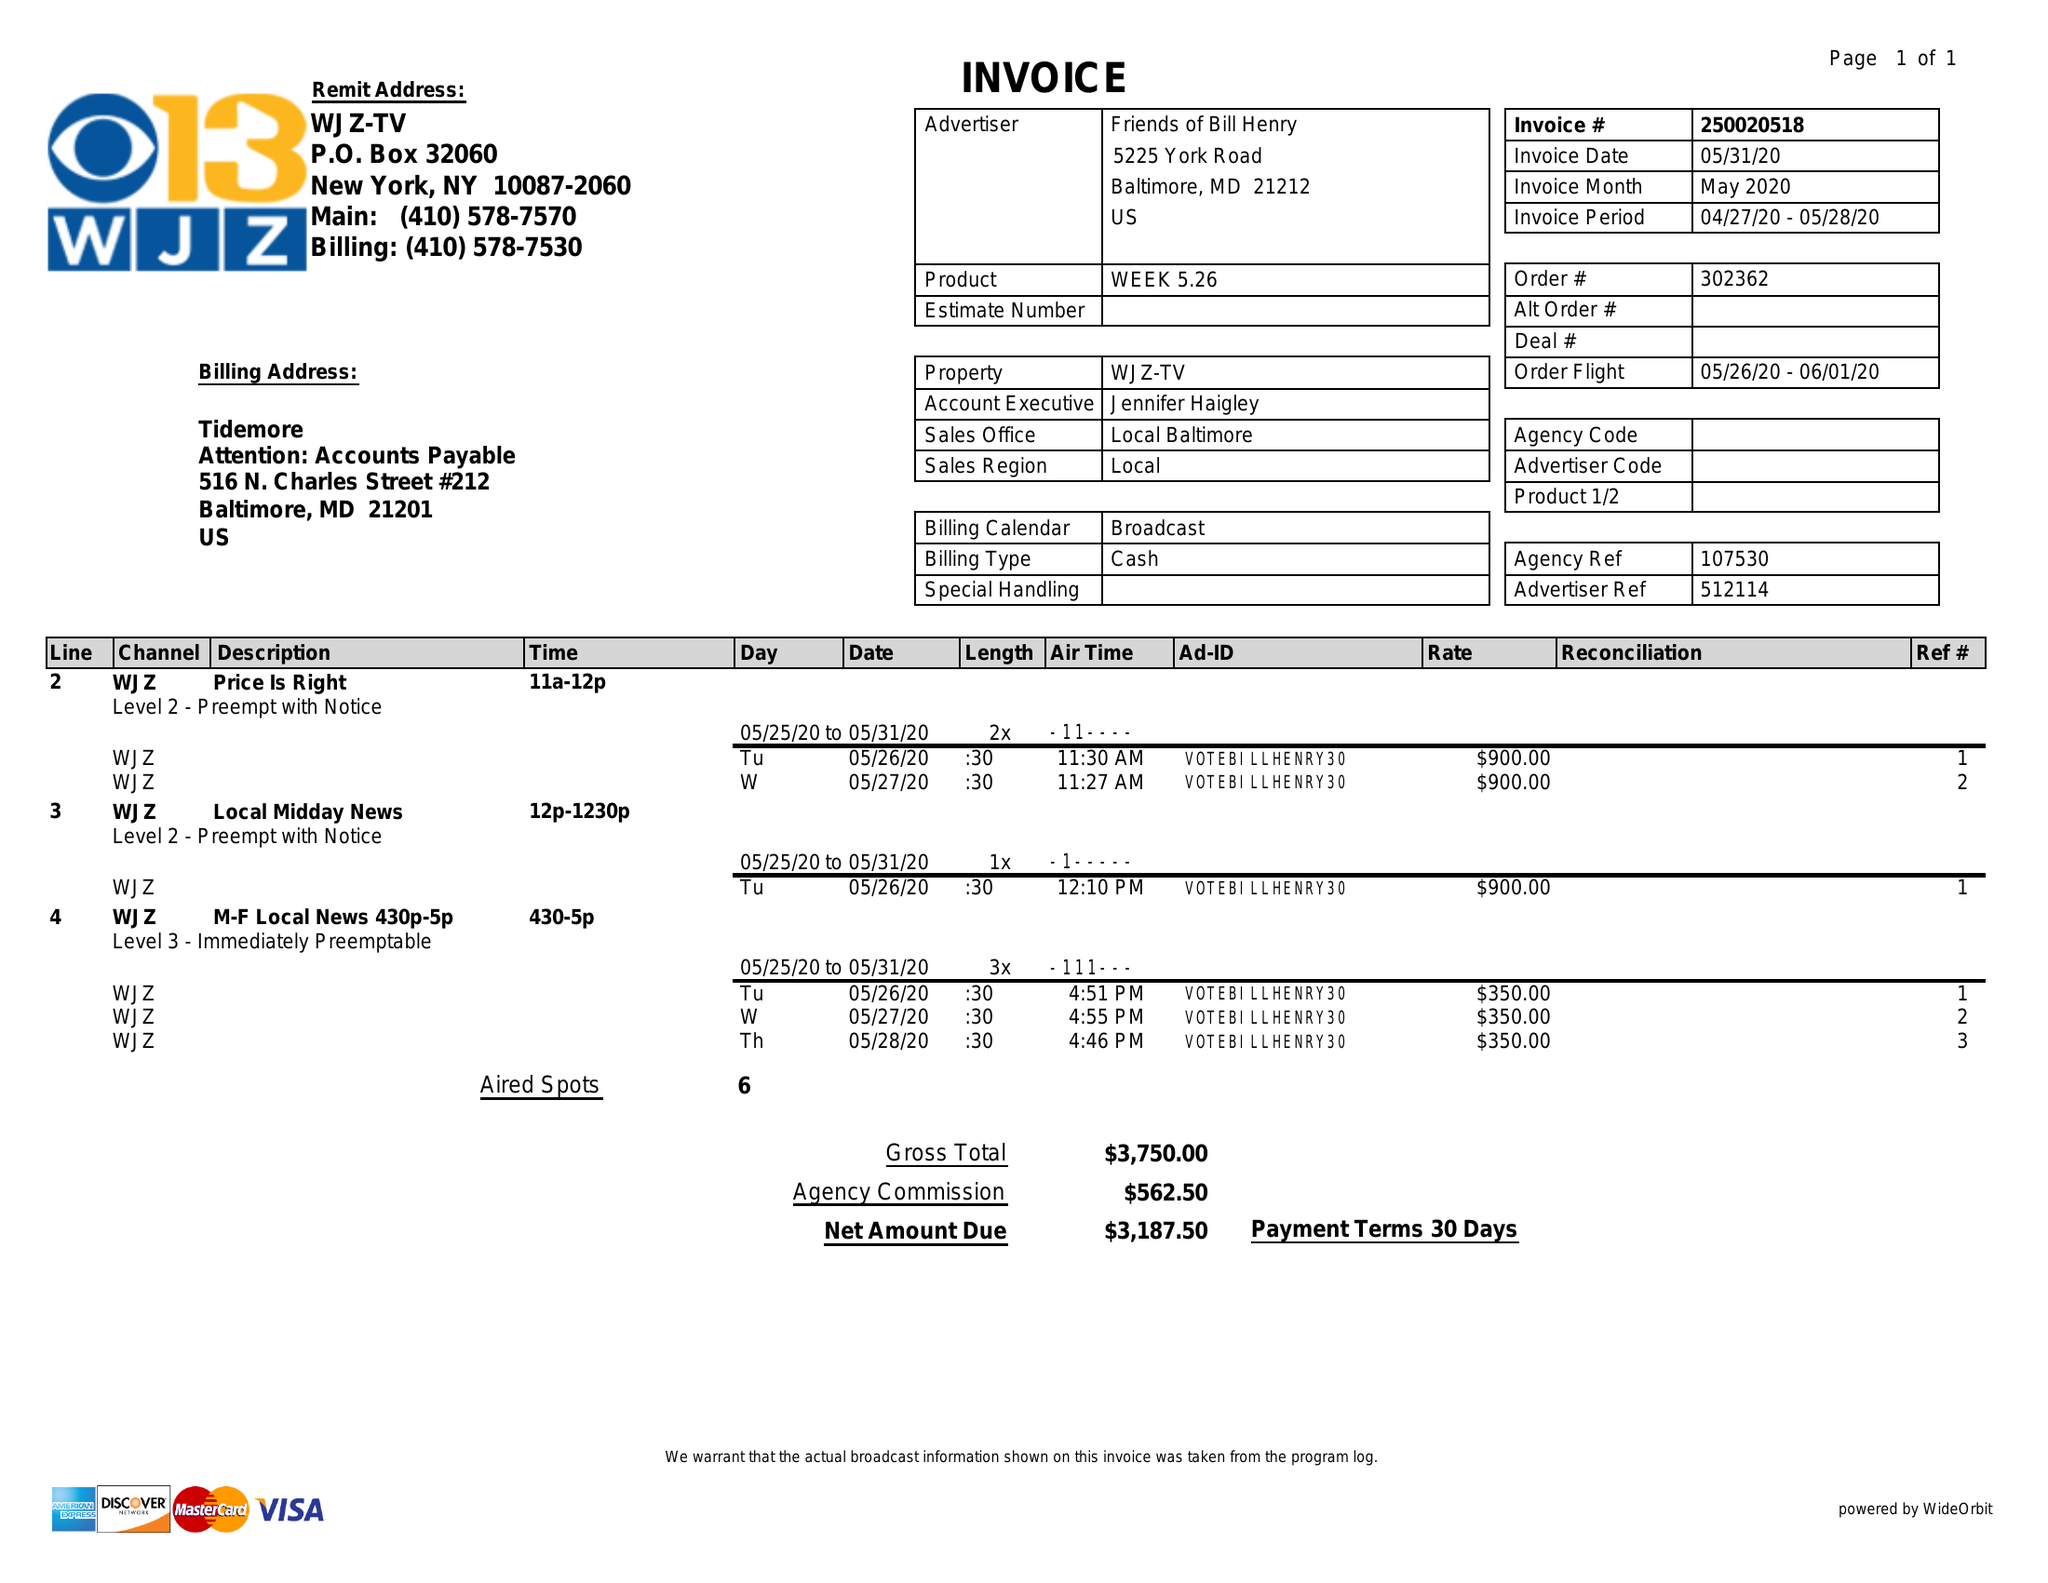What is the value for the contract_num?
Answer the question using a single word or phrase. 250020518 